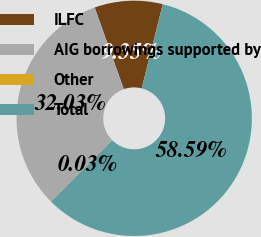Convert chart. <chart><loc_0><loc_0><loc_500><loc_500><pie_chart><fcel>ILFC<fcel>AIG borrowings supported by<fcel>Other<fcel>Total<nl><fcel>9.35%<fcel>32.03%<fcel>0.03%<fcel>58.6%<nl></chart> 